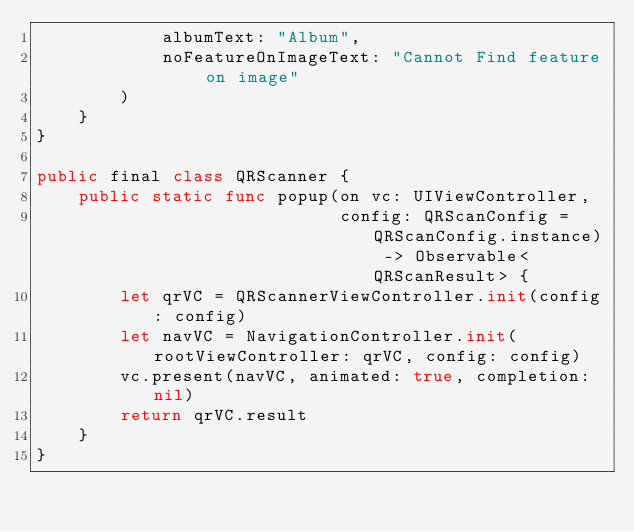<code> <loc_0><loc_0><loc_500><loc_500><_Swift_>            albumText: "Album",
            noFeatureOnImageText: "Cannot Find feature on image"
        )
    }
}

public final class QRScanner {
    public static func popup(on vc: UIViewController,
                             config: QRScanConfig = QRScanConfig.instance) -> Observable<QRScanResult> {
        let qrVC = QRScannerViewController.init(config: config)
        let navVC = NavigationController.init(rootViewController: qrVC, config: config)
        vc.present(navVC, animated: true, completion: nil)
        return qrVC.result
    }
}
</code> 